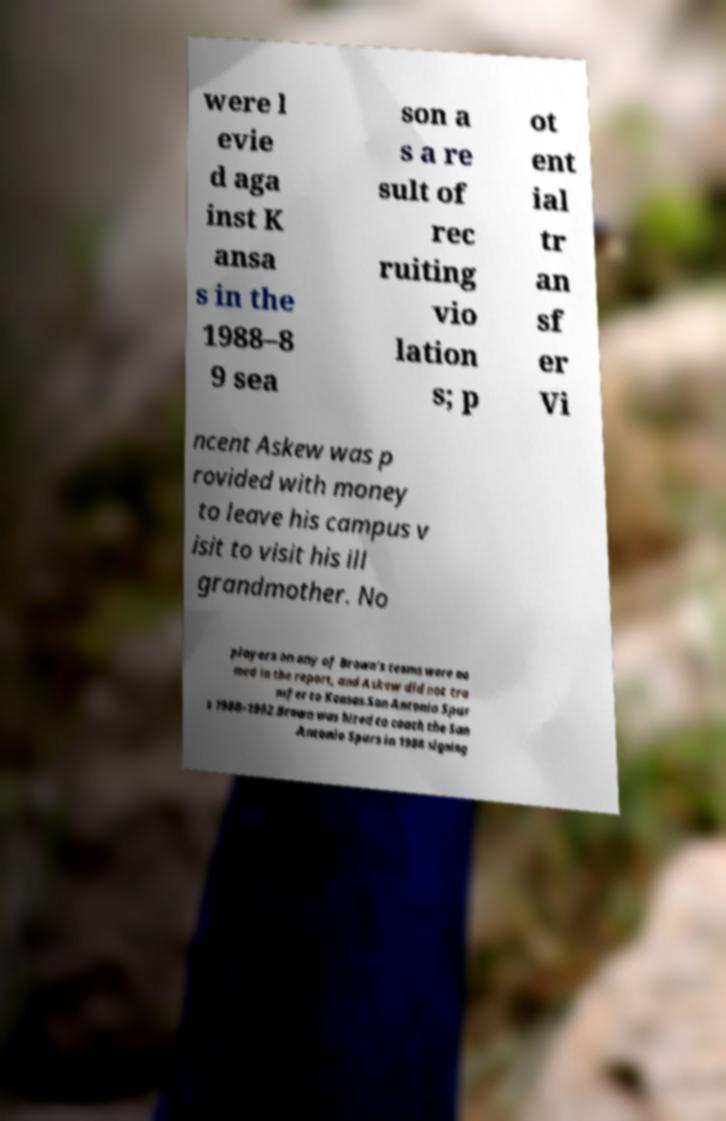I need the written content from this picture converted into text. Can you do that? were l evie d aga inst K ansa s in the 1988–8 9 sea son a s a re sult of rec ruiting vio lation s; p ot ent ial tr an sf er Vi ncent Askew was p rovided with money to leave his campus v isit to visit his ill grandmother. No players on any of Brown's teams were na med in the report, and Askew did not tra nsfer to Kansas.San Antonio Spur s 1988–1992.Brown was hired to coach the San Antonio Spurs in 1988 signing 